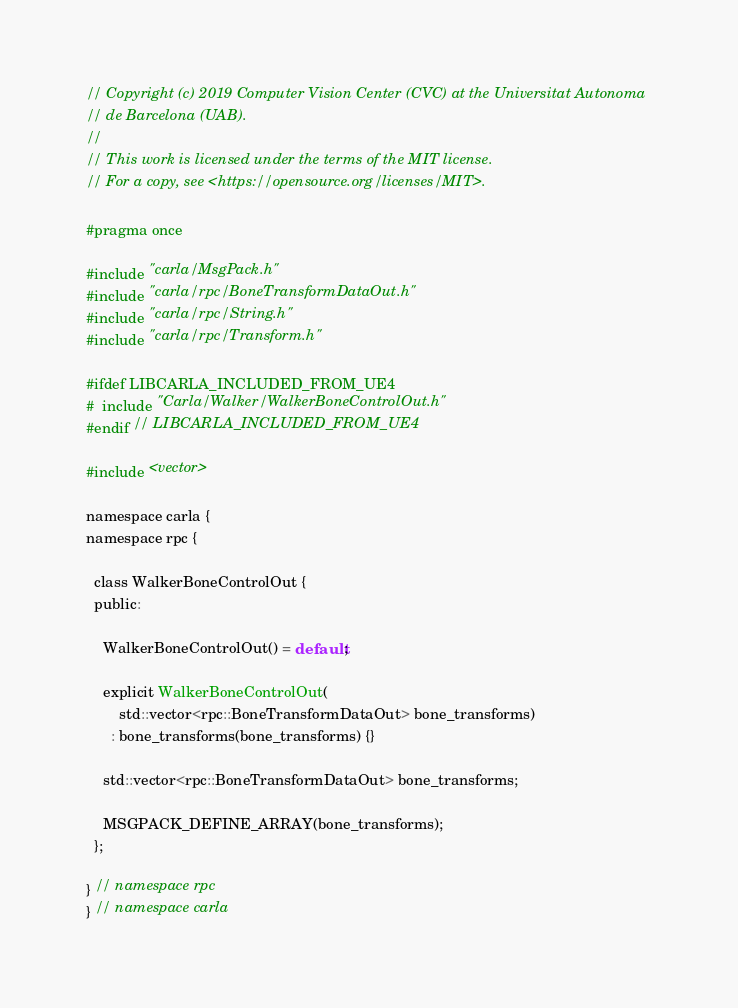<code> <loc_0><loc_0><loc_500><loc_500><_C_>// Copyright (c) 2019 Computer Vision Center (CVC) at the Universitat Autonoma
// de Barcelona (UAB).
//
// This work is licensed under the terms of the MIT license.
// For a copy, see <https://opensource.org/licenses/MIT>.

#pragma once

#include "carla/MsgPack.h"
#include "carla/rpc/BoneTransformDataOut.h"
#include "carla/rpc/String.h"
#include "carla/rpc/Transform.h"

#ifdef LIBCARLA_INCLUDED_FROM_UE4
#  include "Carla/Walker/WalkerBoneControlOut.h"
#endif // LIBCARLA_INCLUDED_FROM_UE4

#include <vector>

namespace carla {
namespace rpc {

  class WalkerBoneControlOut {
  public:

    WalkerBoneControlOut() = default;

    explicit WalkerBoneControlOut(
        std::vector<rpc::BoneTransformDataOut> bone_transforms)
      : bone_transforms(bone_transforms) {}

    std::vector<rpc::BoneTransformDataOut> bone_transforms;

    MSGPACK_DEFINE_ARRAY(bone_transforms);
  };

} // namespace rpc
} // namespace carla
</code> 